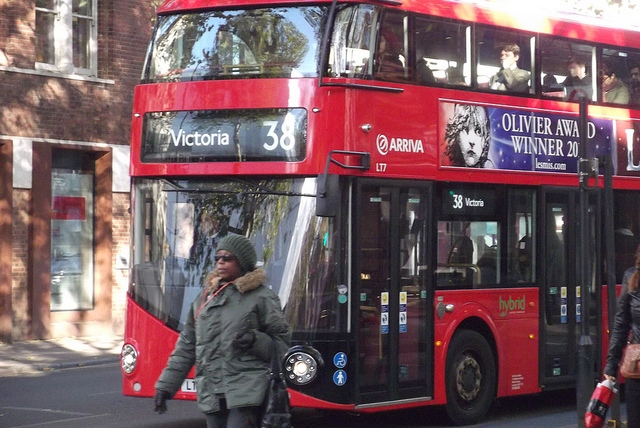Extract all visible text content from this image. Victoria 38 ARRIVA OLIVUER WINNER L 20 D AWA 38 117 L7 